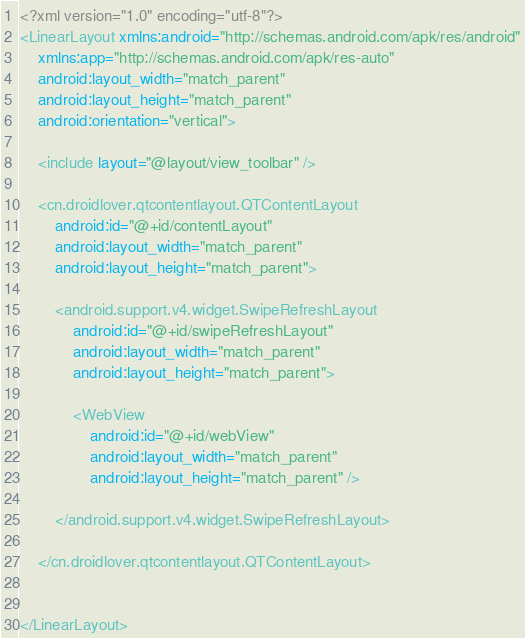Convert code to text. <code><loc_0><loc_0><loc_500><loc_500><_XML_><?xml version="1.0" encoding="utf-8"?>
<LinearLayout xmlns:android="http://schemas.android.com/apk/res/android"
    xmlns:app="http://schemas.android.com/apk/res-auto"
    android:layout_width="match_parent"
    android:layout_height="match_parent"
    android:orientation="vertical">

    <include layout="@layout/view_toolbar" />

    <cn.droidlover.qtcontentlayout.QTContentLayout
        android:id="@+id/contentLayout"
        android:layout_width="match_parent"
        android:layout_height="match_parent">

        <android.support.v4.widget.SwipeRefreshLayout
            android:id="@+id/swipeRefreshLayout"
            android:layout_width="match_parent"
            android:layout_height="match_parent">

            <WebView
                android:id="@+id/webView"
                android:layout_width="match_parent"
                android:layout_height="match_parent" />

        </android.support.v4.widget.SwipeRefreshLayout>

    </cn.droidlover.qtcontentlayout.QTContentLayout>


</LinearLayout></code> 